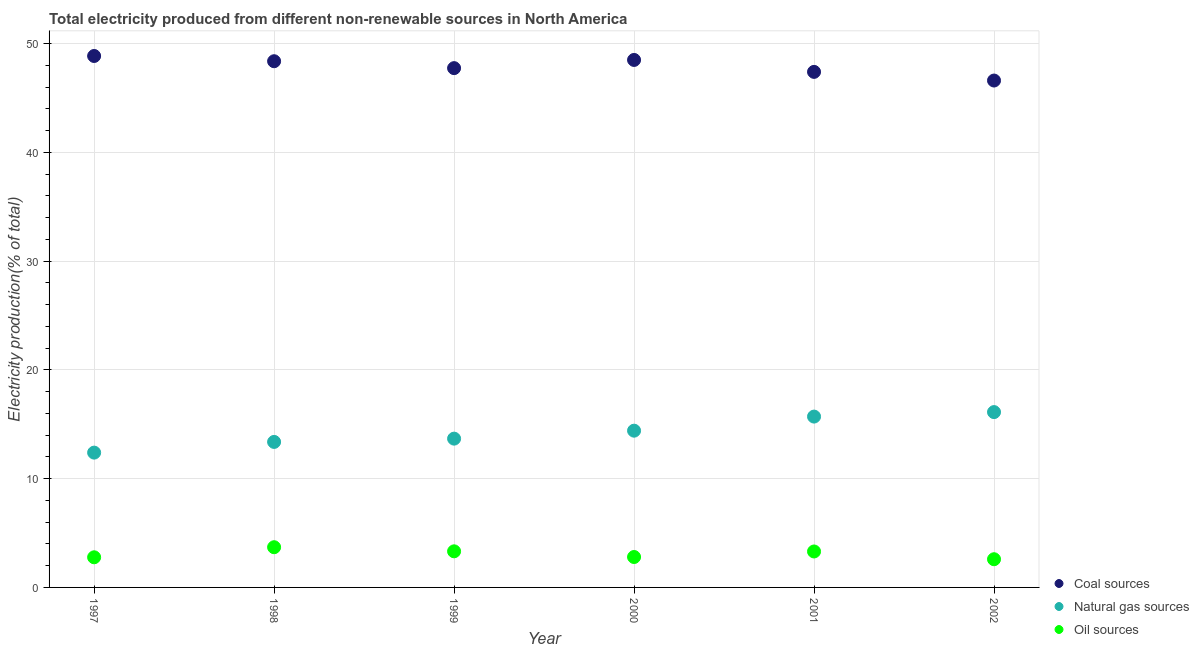What is the percentage of electricity produced by coal in 2000?
Your answer should be very brief. 48.5. Across all years, what is the maximum percentage of electricity produced by natural gas?
Give a very brief answer. 16.12. Across all years, what is the minimum percentage of electricity produced by coal?
Provide a short and direct response. 46.6. In which year was the percentage of electricity produced by oil sources maximum?
Ensure brevity in your answer.  1998. What is the total percentage of electricity produced by coal in the graph?
Your answer should be compact. 287.48. What is the difference between the percentage of electricity produced by natural gas in 1999 and that in 2001?
Keep it short and to the point. -2.03. What is the difference between the percentage of electricity produced by natural gas in 1999 and the percentage of electricity produced by coal in 2002?
Your answer should be compact. -32.92. What is the average percentage of electricity produced by coal per year?
Make the answer very short. 47.91. In the year 2001, what is the difference between the percentage of electricity produced by oil sources and percentage of electricity produced by coal?
Keep it short and to the point. -44.09. In how many years, is the percentage of electricity produced by oil sources greater than 36 %?
Offer a terse response. 0. What is the ratio of the percentage of electricity produced by coal in 2000 to that in 2001?
Your response must be concise. 1.02. Is the difference between the percentage of electricity produced by oil sources in 1997 and 1999 greater than the difference between the percentage of electricity produced by natural gas in 1997 and 1999?
Ensure brevity in your answer.  Yes. What is the difference between the highest and the second highest percentage of electricity produced by oil sources?
Your answer should be compact. 0.38. What is the difference between the highest and the lowest percentage of electricity produced by natural gas?
Provide a short and direct response. 3.73. Is it the case that in every year, the sum of the percentage of electricity produced by coal and percentage of electricity produced by natural gas is greater than the percentage of electricity produced by oil sources?
Your answer should be very brief. Yes. Is the percentage of electricity produced by natural gas strictly greater than the percentage of electricity produced by oil sources over the years?
Your response must be concise. Yes. How many years are there in the graph?
Keep it short and to the point. 6. What is the difference between two consecutive major ticks on the Y-axis?
Your response must be concise. 10. Are the values on the major ticks of Y-axis written in scientific E-notation?
Keep it short and to the point. No. Does the graph contain any zero values?
Provide a short and direct response. No. Does the graph contain grids?
Provide a succinct answer. Yes. Where does the legend appear in the graph?
Offer a very short reply. Bottom right. How are the legend labels stacked?
Make the answer very short. Vertical. What is the title of the graph?
Provide a short and direct response. Total electricity produced from different non-renewable sources in North America. What is the label or title of the X-axis?
Your response must be concise. Year. What is the Electricity production(% of total) in Coal sources in 1997?
Your answer should be very brief. 48.86. What is the Electricity production(% of total) in Natural gas sources in 1997?
Ensure brevity in your answer.  12.39. What is the Electricity production(% of total) in Oil sources in 1997?
Make the answer very short. 2.77. What is the Electricity production(% of total) in Coal sources in 1998?
Offer a very short reply. 48.38. What is the Electricity production(% of total) in Natural gas sources in 1998?
Offer a very short reply. 13.38. What is the Electricity production(% of total) in Oil sources in 1998?
Provide a short and direct response. 3.7. What is the Electricity production(% of total) in Coal sources in 1999?
Keep it short and to the point. 47.74. What is the Electricity production(% of total) of Natural gas sources in 1999?
Keep it short and to the point. 13.68. What is the Electricity production(% of total) in Oil sources in 1999?
Provide a succinct answer. 3.32. What is the Electricity production(% of total) of Coal sources in 2000?
Provide a succinct answer. 48.5. What is the Electricity production(% of total) of Natural gas sources in 2000?
Make the answer very short. 14.41. What is the Electricity production(% of total) in Oil sources in 2000?
Your answer should be compact. 2.8. What is the Electricity production(% of total) of Coal sources in 2001?
Offer a terse response. 47.4. What is the Electricity production(% of total) of Natural gas sources in 2001?
Make the answer very short. 15.71. What is the Electricity production(% of total) of Oil sources in 2001?
Ensure brevity in your answer.  3.31. What is the Electricity production(% of total) in Coal sources in 2002?
Make the answer very short. 46.6. What is the Electricity production(% of total) in Natural gas sources in 2002?
Provide a short and direct response. 16.12. What is the Electricity production(% of total) of Oil sources in 2002?
Your answer should be compact. 2.59. Across all years, what is the maximum Electricity production(% of total) in Coal sources?
Your answer should be compact. 48.86. Across all years, what is the maximum Electricity production(% of total) in Natural gas sources?
Offer a terse response. 16.12. Across all years, what is the maximum Electricity production(% of total) of Oil sources?
Provide a short and direct response. 3.7. Across all years, what is the minimum Electricity production(% of total) in Coal sources?
Your response must be concise. 46.6. Across all years, what is the minimum Electricity production(% of total) of Natural gas sources?
Your response must be concise. 12.39. Across all years, what is the minimum Electricity production(% of total) in Oil sources?
Provide a succinct answer. 2.59. What is the total Electricity production(% of total) in Coal sources in the graph?
Your response must be concise. 287.48. What is the total Electricity production(% of total) in Natural gas sources in the graph?
Provide a short and direct response. 85.69. What is the total Electricity production(% of total) in Oil sources in the graph?
Offer a very short reply. 18.48. What is the difference between the Electricity production(% of total) of Coal sources in 1997 and that in 1998?
Provide a short and direct response. 0.48. What is the difference between the Electricity production(% of total) in Natural gas sources in 1997 and that in 1998?
Make the answer very short. -0.98. What is the difference between the Electricity production(% of total) of Oil sources in 1997 and that in 1998?
Keep it short and to the point. -0.93. What is the difference between the Electricity production(% of total) of Coal sources in 1997 and that in 1999?
Your answer should be very brief. 1.12. What is the difference between the Electricity production(% of total) in Natural gas sources in 1997 and that in 1999?
Keep it short and to the point. -1.29. What is the difference between the Electricity production(% of total) of Oil sources in 1997 and that in 1999?
Offer a very short reply. -0.55. What is the difference between the Electricity production(% of total) of Coal sources in 1997 and that in 2000?
Your answer should be compact. 0.36. What is the difference between the Electricity production(% of total) in Natural gas sources in 1997 and that in 2000?
Ensure brevity in your answer.  -2.02. What is the difference between the Electricity production(% of total) of Oil sources in 1997 and that in 2000?
Provide a short and direct response. -0.03. What is the difference between the Electricity production(% of total) in Coal sources in 1997 and that in 2001?
Your answer should be very brief. 1.46. What is the difference between the Electricity production(% of total) in Natural gas sources in 1997 and that in 2001?
Ensure brevity in your answer.  -3.31. What is the difference between the Electricity production(% of total) in Oil sources in 1997 and that in 2001?
Your answer should be compact. -0.53. What is the difference between the Electricity production(% of total) of Coal sources in 1997 and that in 2002?
Give a very brief answer. 2.26. What is the difference between the Electricity production(% of total) in Natural gas sources in 1997 and that in 2002?
Provide a short and direct response. -3.73. What is the difference between the Electricity production(% of total) in Oil sources in 1997 and that in 2002?
Your answer should be compact. 0.18. What is the difference between the Electricity production(% of total) in Coal sources in 1998 and that in 1999?
Offer a very short reply. 0.64. What is the difference between the Electricity production(% of total) in Natural gas sources in 1998 and that in 1999?
Ensure brevity in your answer.  -0.3. What is the difference between the Electricity production(% of total) of Oil sources in 1998 and that in 1999?
Offer a very short reply. 0.38. What is the difference between the Electricity production(% of total) of Coal sources in 1998 and that in 2000?
Give a very brief answer. -0.12. What is the difference between the Electricity production(% of total) of Natural gas sources in 1998 and that in 2000?
Offer a terse response. -1.03. What is the difference between the Electricity production(% of total) of Oil sources in 1998 and that in 2000?
Your response must be concise. 0.9. What is the difference between the Electricity production(% of total) of Coal sources in 1998 and that in 2001?
Give a very brief answer. 0.98. What is the difference between the Electricity production(% of total) in Natural gas sources in 1998 and that in 2001?
Make the answer very short. -2.33. What is the difference between the Electricity production(% of total) in Oil sources in 1998 and that in 2001?
Offer a very short reply. 0.39. What is the difference between the Electricity production(% of total) in Coal sources in 1998 and that in 2002?
Make the answer very short. 1.78. What is the difference between the Electricity production(% of total) in Natural gas sources in 1998 and that in 2002?
Your answer should be compact. -2.74. What is the difference between the Electricity production(% of total) in Oil sources in 1998 and that in 2002?
Keep it short and to the point. 1.1. What is the difference between the Electricity production(% of total) in Coal sources in 1999 and that in 2000?
Offer a very short reply. -0.75. What is the difference between the Electricity production(% of total) in Natural gas sources in 1999 and that in 2000?
Offer a terse response. -0.73. What is the difference between the Electricity production(% of total) in Oil sources in 1999 and that in 2000?
Ensure brevity in your answer.  0.52. What is the difference between the Electricity production(% of total) in Coal sources in 1999 and that in 2001?
Offer a terse response. 0.34. What is the difference between the Electricity production(% of total) in Natural gas sources in 1999 and that in 2001?
Give a very brief answer. -2.03. What is the difference between the Electricity production(% of total) of Oil sources in 1999 and that in 2001?
Your answer should be very brief. 0.01. What is the difference between the Electricity production(% of total) in Coal sources in 1999 and that in 2002?
Offer a terse response. 1.14. What is the difference between the Electricity production(% of total) in Natural gas sources in 1999 and that in 2002?
Your response must be concise. -2.44. What is the difference between the Electricity production(% of total) of Oil sources in 1999 and that in 2002?
Offer a terse response. 0.73. What is the difference between the Electricity production(% of total) in Coal sources in 2000 and that in 2001?
Ensure brevity in your answer.  1.1. What is the difference between the Electricity production(% of total) of Natural gas sources in 2000 and that in 2001?
Offer a terse response. -1.3. What is the difference between the Electricity production(% of total) in Oil sources in 2000 and that in 2001?
Provide a short and direct response. -0.51. What is the difference between the Electricity production(% of total) of Coal sources in 2000 and that in 2002?
Your response must be concise. 1.89. What is the difference between the Electricity production(% of total) of Natural gas sources in 2000 and that in 2002?
Provide a short and direct response. -1.71. What is the difference between the Electricity production(% of total) of Oil sources in 2000 and that in 2002?
Keep it short and to the point. 0.2. What is the difference between the Electricity production(% of total) of Coal sources in 2001 and that in 2002?
Provide a succinct answer. 0.8. What is the difference between the Electricity production(% of total) of Natural gas sources in 2001 and that in 2002?
Make the answer very short. -0.41. What is the difference between the Electricity production(% of total) in Oil sources in 2001 and that in 2002?
Ensure brevity in your answer.  0.71. What is the difference between the Electricity production(% of total) in Coal sources in 1997 and the Electricity production(% of total) in Natural gas sources in 1998?
Give a very brief answer. 35.48. What is the difference between the Electricity production(% of total) of Coal sources in 1997 and the Electricity production(% of total) of Oil sources in 1998?
Offer a terse response. 45.16. What is the difference between the Electricity production(% of total) in Natural gas sources in 1997 and the Electricity production(% of total) in Oil sources in 1998?
Ensure brevity in your answer.  8.7. What is the difference between the Electricity production(% of total) of Coal sources in 1997 and the Electricity production(% of total) of Natural gas sources in 1999?
Keep it short and to the point. 35.18. What is the difference between the Electricity production(% of total) of Coal sources in 1997 and the Electricity production(% of total) of Oil sources in 1999?
Your answer should be compact. 45.54. What is the difference between the Electricity production(% of total) of Natural gas sources in 1997 and the Electricity production(% of total) of Oil sources in 1999?
Keep it short and to the point. 9.07. What is the difference between the Electricity production(% of total) in Coal sources in 1997 and the Electricity production(% of total) in Natural gas sources in 2000?
Your answer should be compact. 34.45. What is the difference between the Electricity production(% of total) in Coal sources in 1997 and the Electricity production(% of total) in Oil sources in 2000?
Offer a terse response. 46.06. What is the difference between the Electricity production(% of total) of Natural gas sources in 1997 and the Electricity production(% of total) of Oil sources in 2000?
Offer a terse response. 9.6. What is the difference between the Electricity production(% of total) of Coal sources in 1997 and the Electricity production(% of total) of Natural gas sources in 2001?
Provide a succinct answer. 33.15. What is the difference between the Electricity production(% of total) of Coal sources in 1997 and the Electricity production(% of total) of Oil sources in 2001?
Offer a very short reply. 45.56. What is the difference between the Electricity production(% of total) of Natural gas sources in 1997 and the Electricity production(% of total) of Oil sources in 2001?
Offer a terse response. 9.09. What is the difference between the Electricity production(% of total) in Coal sources in 1997 and the Electricity production(% of total) in Natural gas sources in 2002?
Make the answer very short. 32.74. What is the difference between the Electricity production(% of total) in Coal sources in 1997 and the Electricity production(% of total) in Oil sources in 2002?
Offer a terse response. 46.27. What is the difference between the Electricity production(% of total) of Natural gas sources in 1997 and the Electricity production(% of total) of Oil sources in 2002?
Offer a terse response. 9.8. What is the difference between the Electricity production(% of total) of Coal sources in 1998 and the Electricity production(% of total) of Natural gas sources in 1999?
Offer a terse response. 34.7. What is the difference between the Electricity production(% of total) in Coal sources in 1998 and the Electricity production(% of total) in Oil sources in 1999?
Make the answer very short. 45.06. What is the difference between the Electricity production(% of total) in Natural gas sources in 1998 and the Electricity production(% of total) in Oil sources in 1999?
Offer a terse response. 10.06. What is the difference between the Electricity production(% of total) of Coal sources in 1998 and the Electricity production(% of total) of Natural gas sources in 2000?
Offer a very short reply. 33.97. What is the difference between the Electricity production(% of total) in Coal sources in 1998 and the Electricity production(% of total) in Oil sources in 2000?
Give a very brief answer. 45.58. What is the difference between the Electricity production(% of total) of Natural gas sources in 1998 and the Electricity production(% of total) of Oil sources in 2000?
Keep it short and to the point. 10.58. What is the difference between the Electricity production(% of total) of Coal sources in 1998 and the Electricity production(% of total) of Natural gas sources in 2001?
Your answer should be very brief. 32.67. What is the difference between the Electricity production(% of total) of Coal sources in 1998 and the Electricity production(% of total) of Oil sources in 2001?
Give a very brief answer. 45.07. What is the difference between the Electricity production(% of total) in Natural gas sources in 1998 and the Electricity production(% of total) in Oil sources in 2001?
Give a very brief answer. 10.07. What is the difference between the Electricity production(% of total) of Coal sources in 1998 and the Electricity production(% of total) of Natural gas sources in 2002?
Your response must be concise. 32.26. What is the difference between the Electricity production(% of total) of Coal sources in 1998 and the Electricity production(% of total) of Oil sources in 2002?
Your response must be concise. 45.79. What is the difference between the Electricity production(% of total) in Natural gas sources in 1998 and the Electricity production(% of total) in Oil sources in 2002?
Provide a short and direct response. 10.79. What is the difference between the Electricity production(% of total) in Coal sources in 1999 and the Electricity production(% of total) in Natural gas sources in 2000?
Keep it short and to the point. 33.33. What is the difference between the Electricity production(% of total) of Coal sources in 1999 and the Electricity production(% of total) of Oil sources in 2000?
Offer a very short reply. 44.95. What is the difference between the Electricity production(% of total) of Natural gas sources in 1999 and the Electricity production(% of total) of Oil sources in 2000?
Give a very brief answer. 10.88. What is the difference between the Electricity production(% of total) in Coal sources in 1999 and the Electricity production(% of total) in Natural gas sources in 2001?
Offer a very short reply. 32.04. What is the difference between the Electricity production(% of total) in Coal sources in 1999 and the Electricity production(% of total) in Oil sources in 2001?
Keep it short and to the point. 44.44. What is the difference between the Electricity production(% of total) of Natural gas sources in 1999 and the Electricity production(% of total) of Oil sources in 2001?
Keep it short and to the point. 10.37. What is the difference between the Electricity production(% of total) in Coal sources in 1999 and the Electricity production(% of total) in Natural gas sources in 2002?
Keep it short and to the point. 31.62. What is the difference between the Electricity production(% of total) of Coal sources in 1999 and the Electricity production(% of total) of Oil sources in 2002?
Keep it short and to the point. 45.15. What is the difference between the Electricity production(% of total) in Natural gas sources in 1999 and the Electricity production(% of total) in Oil sources in 2002?
Provide a succinct answer. 11.09. What is the difference between the Electricity production(% of total) in Coal sources in 2000 and the Electricity production(% of total) in Natural gas sources in 2001?
Provide a succinct answer. 32.79. What is the difference between the Electricity production(% of total) of Coal sources in 2000 and the Electricity production(% of total) of Oil sources in 2001?
Give a very brief answer. 45.19. What is the difference between the Electricity production(% of total) in Natural gas sources in 2000 and the Electricity production(% of total) in Oil sources in 2001?
Your answer should be very brief. 11.11. What is the difference between the Electricity production(% of total) in Coal sources in 2000 and the Electricity production(% of total) in Natural gas sources in 2002?
Provide a short and direct response. 32.38. What is the difference between the Electricity production(% of total) in Coal sources in 2000 and the Electricity production(% of total) in Oil sources in 2002?
Make the answer very short. 45.9. What is the difference between the Electricity production(% of total) of Natural gas sources in 2000 and the Electricity production(% of total) of Oil sources in 2002?
Provide a succinct answer. 11.82. What is the difference between the Electricity production(% of total) of Coal sources in 2001 and the Electricity production(% of total) of Natural gas sources in 2002?
Your answer should be very brief. 31.28. What is the difference between the Electricity production(% of total) in Coal sources in 2001 and the Electricity production(% of total) in Oil sources in 2002?
Your answer should be very brief. 44.81. What is the difference between the Electricity production(% of total) in Natural gas sources in 2001 and the Electricity production(% of total) in Oil sources in 2002?
Give a very brief answer. 13.11. What is the average Electricity production(% of total) in Coal sources per year?
Make the answer very short. 47.91. What is the average Electricity production(% of total) in Natural gas sources per year?
Your response must be concise. 14.28. What is the average Electricity production(% of total) in Oil sources per year?
Your answer should be compact. 3.08. In the year 1997, what is the difference between the Electricity production(% of total) in Coal sources and Electricity production(% of total) in Natural gas sources?
Provide a short and direct response. 36.47. In the year 1997, what is the difference between the Electricity production(% of total) of Coal sources and Electricity production(% of total) of Oil sources?
Keep it short and to the point. 46.09. In the year 1997, what is the difference between the Electricity production(% of total) of Natural gas sources and Electricity production(% of total) of Oil sources?
Make the answer very short. 9.62. In the year 1998, what is the difference between the Electricity production(% of total) of Coal sources and Electricity production(% of total) of Natural gas sources?
Give a very brief answer. 35. In the year 1998, what is the difference between the Electricity production(% of total) of Coal sources and Electricity production(% of total) of Oil sources?
Your response must be concise. 44.68. In the year 1998, what is the difference between the Electricity production(% of total) in Natural gas sources and Electricity production(% of total) in Oil sources?
Make the answer very short. 9.68. In the year 1999, what is the difference between the Electricity production(% of total) in Coal sources and Electricity production(% of total) in Natural gas sources?
Your answer should be very brief. 34.06. In the year 1999, what is the difference between the Electricity production(% of total) in Coal sources and Electricity production(% of total) in Oil sources?
Make the answer very short. 44.42. In the year 1999, what is the difference between the Electricity production(% of total) of Natural gas sources and Electricity production(% of total) of Oil sources?
Ensure brevity in your answer.  10.36. In the year 2000, what is the difference between the Electricity production(% of total) of Coal sources and Electricity production(% of total) of Natural gas sources?
Make the answer very short. 34.09. In the year 2000, what is the difference between the Electricity production(% of total) of Coal sources and Electricity production(% of total) of Oil sources?
Provide a succinct answer. 45.7. In the year 2000, what is the difference between the Electricity production(% of total) of Natural gas sources and Electricity production(% of total) of Oil sources?
Provide a succinct answer. 11.62. In the year 2001, what is the difference between the Electricity production(% of total) of Coal sources and Electricity production(% of total) of Natural gas sources?
Keep it short and to the point. 31.69. In the year 2001, what is the difference between the Electricity production(% of total) in Coal sources and Electricity production(% of total) in Oil sources?
Make the answer very short. 44.09. In the year 2001, what is the difference between the Electricity production(% of total) of Natural gas sources and Electricity production(% of total) of Oil sources?
Make the answer very short. 12.4. In the year 2002, what is the difference between the Electricity production(% of total) in Coal sources and Electricity production(% of total) in Natural gas sources?
Make the answer very short. 30.48. In the year 2002, what is the difference between the Electricity production(% of total) of Coal sources and Electricity production(% of total) of Oil sources?
Ensure brevity in your answer.  44.01. In the year 2002, what is the difference between the Electricity production(% of total) in Natural gas sources and Electricity production(% of total) in Oil sources?
Your answer should be very brief. 13.53. What is the ratio of the Electricity production(% of total) of Coal sources in 1997 to that in 1998?
Provide a succinct answer. 1.01. What is the ratio of the Electricity production(% of total) of Natural gas sources in 1997 to that in 1998?
Give a very brief answer. 0.93. What is the ratio of the Electricity production(% of total) in Oil sources in 1997 to that in 1998?
Your answer should be very brief. 0.75. What is the ratio of the Electricity production(% of total) in Coal sources in 1997 to that in 1999?
Offer a very short reply. 1.02. What is the ratio of the Electricity production(% of total) of Natural gas sources in 1997 to that in 1999?
Provide a short and direct response. 0.91. What is the ratio of the Electricity production(% of total) of Oil sources in 1997 to that in 1999?
Your answer should be very brief. 0.83. What is the ratio of the Electricity production(% of total) in Coal sources in 1997 to that in 2000?
Give a very brief answer. 1.01. What is the ratio of the Electricity production(% of total) in Natural gas sources in 1997 to that in 2000?
Make the answer very short. 0.86. What is the ratio of the Electricity production(% of total) in Oil sources in 1997 to that in 2000?
Your answer should be very brief. 0.99. What is the ratio of the Electricity production(% of total) in Coal sources in 1997 to that in 2001?
Ensure brevity in your answer.  1.03. What is the ratio of the Electricity production(% of total) in Natural gas sources in 1997 to that in 2001?
Provide a short and direct response. 0.79. What is the ratio of the Electricity production(% of total) in Oil sources in 1997 to that in 2001?
Your answer should be very brief. 0.84. What is the ratio of the Electricity production(% of total) in Coal sources in 1997 to that in 2002?
Provide a succinct answer. 1.05. What is the ratio of the Electricity production(% of total) of Natural gas sources in 1997 to that in 2002?
Make the answer very short. 0.77. What is the ratio of the Electricity production(% of total) of Oil sources in 1997 to that in 2002?
Your response must be concise. 1.07. What is the ratio of the Electricity production(% of total) of Coal sources in 1998 to that in 1999?
Give a very brief answer. 1.01. What is the ratio of the Electricity production(% of total) of Natural gas sources in 1998 to that in 1999?
Provide a succinct answer. 0.98. What is the ratio of the Electricity production(% of total) of Oil sources in 1998 to that in 1999?
Offer a terse response. 1.11. What is the ratio of the Electricity production(% of total) in Natural gas sources in 1998 to that in 2000?
Your answer should be very brief. 0.93. What is the ratio of the Electricity production(% of total) in Oil sources in 1998 to that in 2000?
Your response must be concise. 1.32. What is the ratio of the Electricity production(% of total) in Coal sources in 1998 to that in 2001?
Offer a very short reply. 1.02. What is the ratio of the Electricity production(% of total) of Natural gas sources in 1998 to that in 2001?
Keep it short and to the point. 0.85. What is the ratio of the Electricity production(% of total) of Oil sources in 1998 to that in 2001?
Your answer should be very brief. 1.12. What is the ratio of the Electricity production(% of total) in Coal sources in 1998 to that in 2002?
Ensure brevity in your answer.  1.04. What is the ratio of the Electricity production(% of total) in Natural gas sources in 1998 to that in 2002?
Make the answer very short. 0.83. What is the ratio of the Electricity production(% of total) in Oil sources in 1998 to that in 2002?
Provide a succinct answer. 1.43. What is the ratio of the Electricity production(% of total) of Coal sources in 1999 to that in 2000?
Offer a terse response. 0.98. What is the ratio of the Electricity production(% of total) in Natural gas sources in 1999 to that in 2000?
Give a very brief answer. 0.95. What is the ratio of the Electricity production(% of total) in Oil sources in 1999 to that in 2000?
Your answer should be very brief. 1.19. What is the ratio of the Electricity production(% of total) in Coal sources in 1999 to that in 2001?
Provide a succinct answer. 1.01. What is the ratio of the Electricity production(% of total) in Natural gas sources in 1999 to that in 2001?
Ensure brevity in your answer.  0.87. What is the ratio of the Electricity production(% of total) of Oil sources in 1999 to that in 2001?
Offer a terse response. 1. What is the ratio of the Electricity production(% of total) of Coal sources in 1999 to that in 2002?
Offer a terse response. 1.02. What is the ratio of the Electricity production(% of total) of Natural gas sources in 1999 to that in 2002?
Ensure brevity in your answer.  0.85. What is the ratio of the Electricity production(% of total) of Oil sources in 1999 to that in 2002?
Your answer should be very brief. 1.28. What is the ratio of the Electricity production(% of total) in Coal sources in 2000 to that in 2001?
Provide a succinct answer. 1.02. What is the ratio of the Electricity production(% of total) of Natural gas sources in 2000 to that in 2001?
Make the answer very short. 0.92. What is the ratio of the Electricity production(% of total) of Oil sources in 2000 to that in 2001?
Your answer should be very brief. 0.85. What is the ratio of the Electricity production(% of total) in Coal sources in 2000 to that in 2002?
Your answer should be compact. 1.04. What is the ratio of the Electricity production(% of total) in Natural gas sources in 2000 to that in 2002?
Your answer should be very brief. 0.89. What is the ratio of the Electricity production(% of total) in Oil sources in 2000 to that in 2002?
Your answer should be compact. 1.08. What is the ratio of the Electricity production(% of total) in Coal sources in 2001 to that in 2002?
Your answer should be very brief. 1.02. What is the ratio of the Electricity production(% of total) of Natural gas sources in 2001 to that in 2002?
Give a very brief answer. 0.97. What is the ratio of the Electricity production(% of total) in Oil sources in 2001 to that in 2002?
Ensure brevity in your answer.  1.27. What is the difference between the highest and the second highest Electricity production(% of total) in Coal sources?
Give a very brief answer. 0.36. What is the difference between the highest and the second highest Electricity production(% of total) of Natural gas sources?
Make the answer very short. 0.41. What is the difference between the highest and the second highest Electricity production(% of total) in Oil sources?
Offer a very short reply. 0.38. What is the difference between the highest and the lowest Electricity production(% of total) in Coal sources?
Make the answer very short. 2.26. What is the difference between the highest and the lowest Electricity production(% of total) of Natural gas sources?
Your answer should be very brief. 3.73. What is the difference between the highest and the lowest Electricity production(% of total) in Oil sources?
Provide a succinct answer. 1.1. 